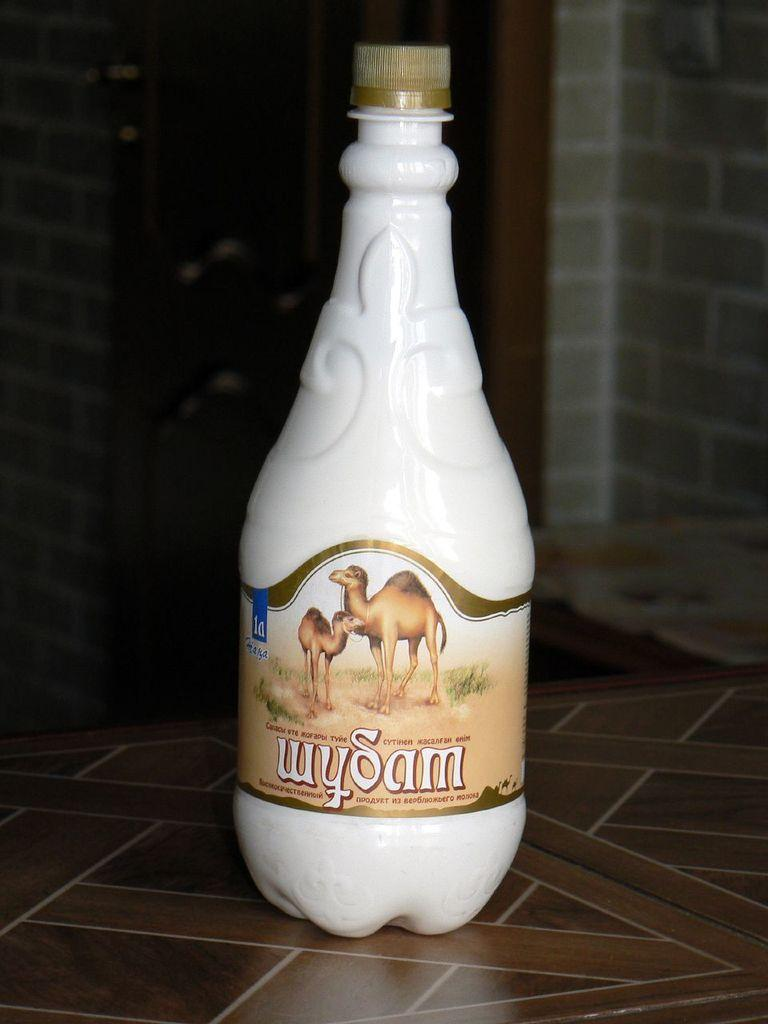<image>
Render a clear and concise summary of the photo. A bottle with camels on it has a label reading wySam. 